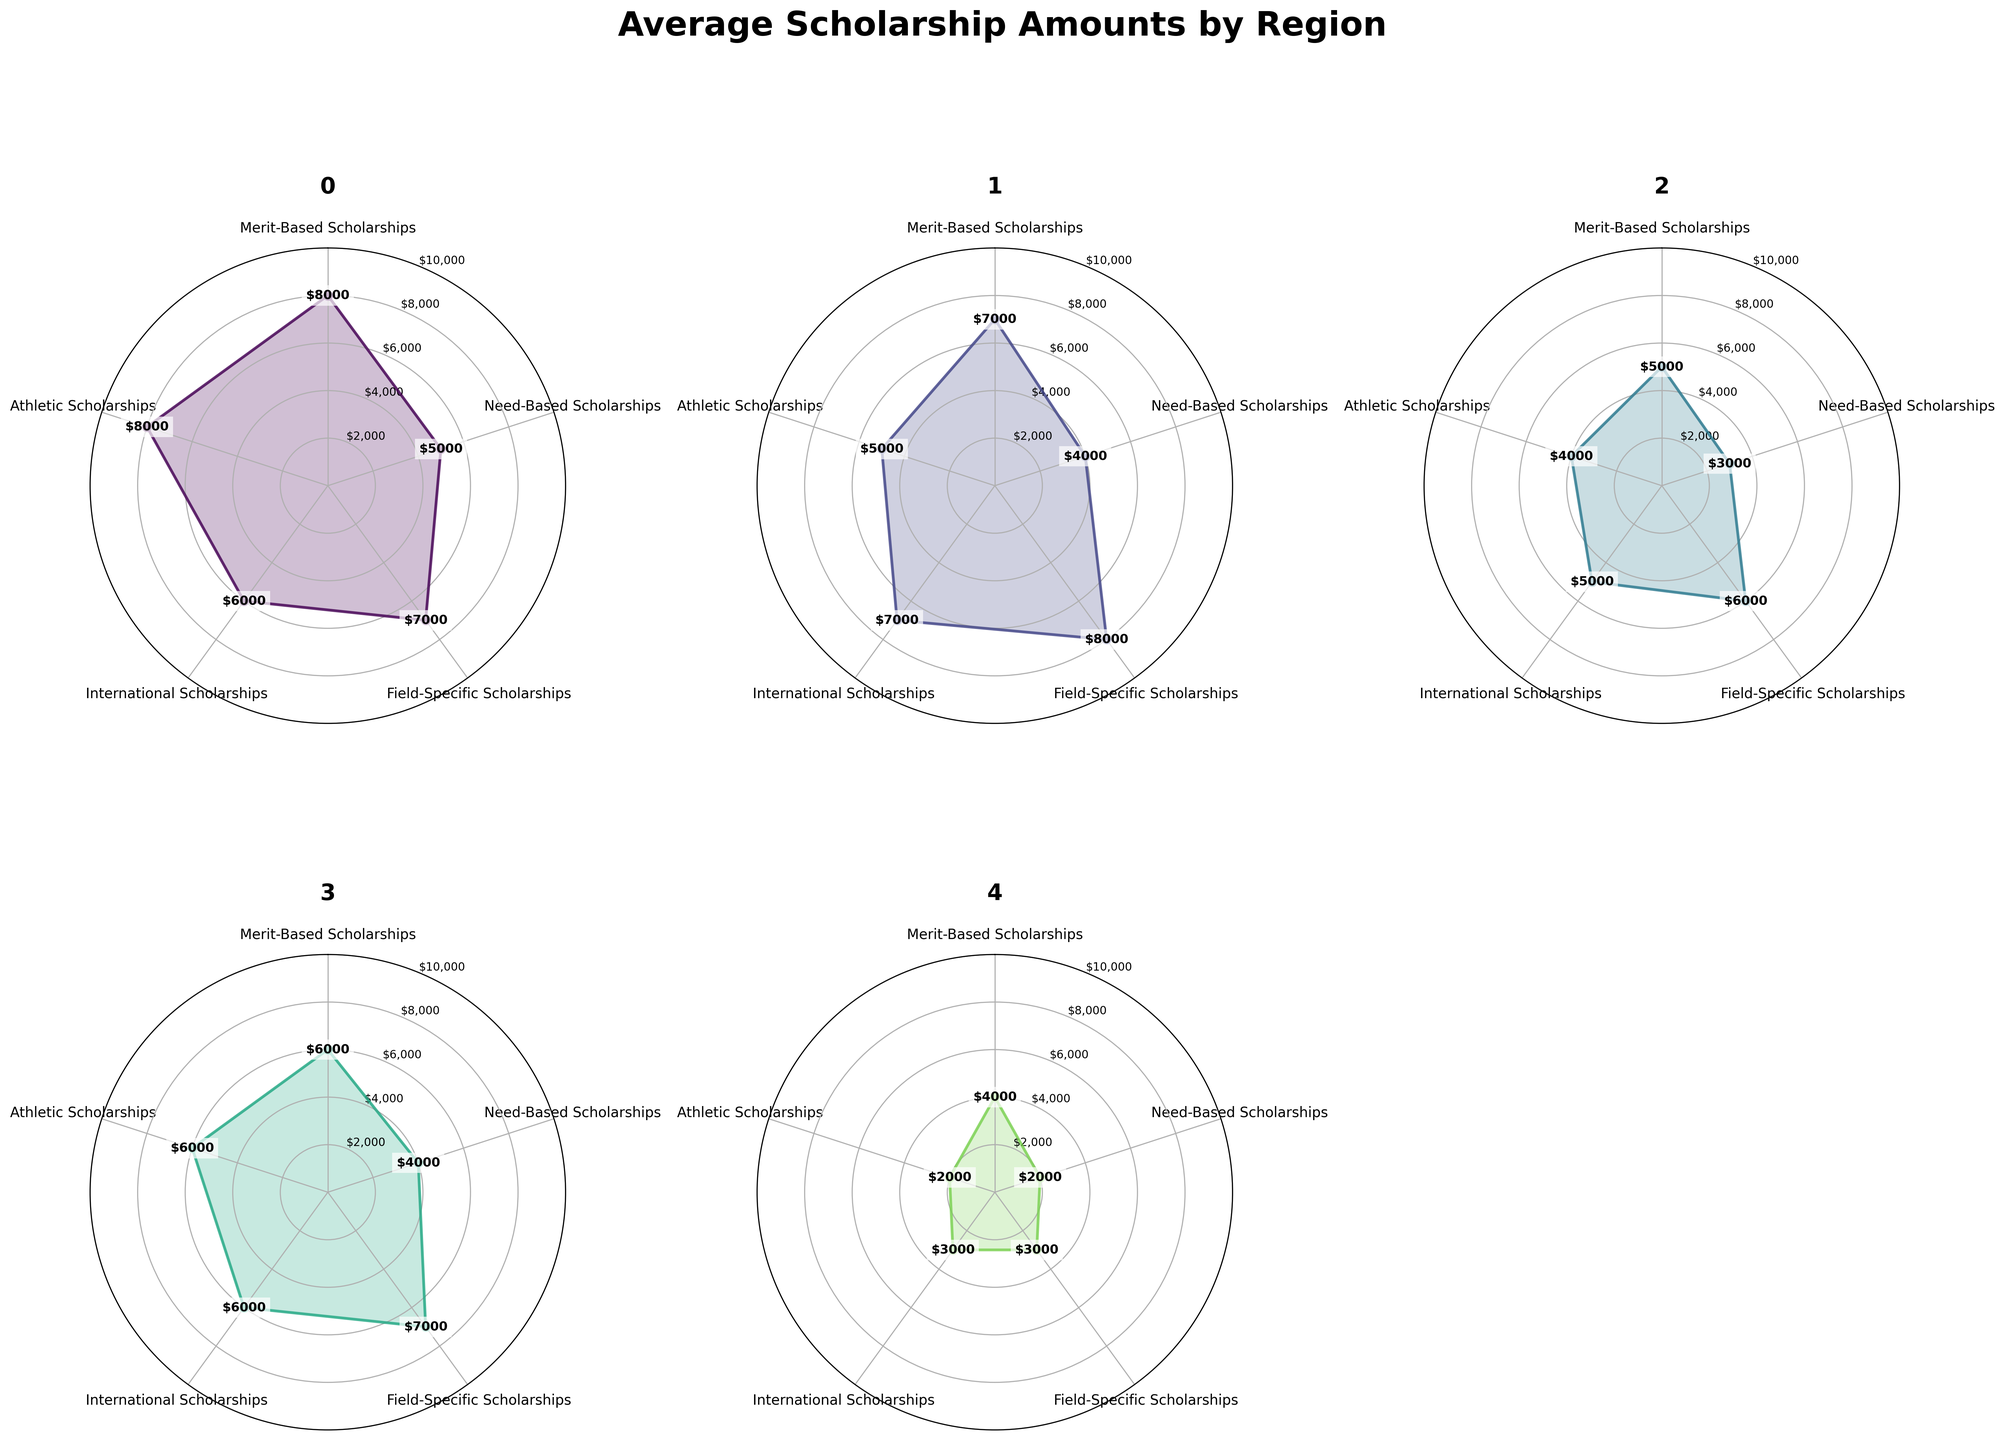What is the highest average amount awarded for merit-based scholarships across all regions? From the radar plots, the highest value for merit-based scholarships can be identified by looking at the point furthest from the center on the "Merit-Based Scholarships" axis. North America has an $8,000 figure.
Answer: $8,000 Which region has the lowest average amount for athletic scholarships? The smallest value for athletic scholarships can be identified by finding the point closest to the center on the "Athletic Scholarships" axis. South America has the lowest value of $1,000.
Answer: South America What is the difference between the average amounts awarded for need-based scholarships in North America and Europe? Need-based scholarships in North America have an average amount of $5,000, while Europe has $4,000. The difference is $5,000 - $4,000.
Answer: $1,000 What regions have a higher average amount for field-specific scholarships than for international scholarships? By comparing the heights of the points on the "Field-Specific Scholarships" and "International Scholarships" axes for each region, we find that Europe and Australia have higher values for field-specific ($8,000 and $7,000 respectively) than for international scholarships ($7,000 and $6,000 respectively).
Answer: Europe, Australia Which region offers the most balanced scholarships across all categories? A region has balanced scholarships if its plot is nearly circular, indicating similar values across all categories. North America and Australia appear to offer similarly balanced scholarships since their plots have the most uniform shapes.
Answer: North America, Australia What is the overall average amount awarded for scholarships in Africa? The values in Africa are $4,000 for Merit-Based, $2,000 for Need-Based, $3,000 for Field-Specific, $3,000 for International, and $2,000 for Athletic. The overall average is (4000 + 2000 + 3000 + 3000 + 2000)/5.
Answer: $2,800 How does the merit-based scholarship in Europe compare to the need-based scholarship in Asia? Merit-based in Europe is $7,000 while need-based in Asia is $3,000. Merit-based in Europe is higher than need-based in Asia.
Answer: Merit-based is higher Which regions provide more than $6,000 for international scholarships? By observing the values on the "International Scholarships" axis, North America and Europe (both $7,000) provide more than $6,000 for international scholarships.
Answer: North America, Europe What is the sum of the average scholarship amounts awarded in South America for merit-based and field-specific scholarships? The values for South America are $3,000 for Merit-Based and $2,500 for Field-Specific. The sum is $3,000 + $2,500.
Answer: $5,500 